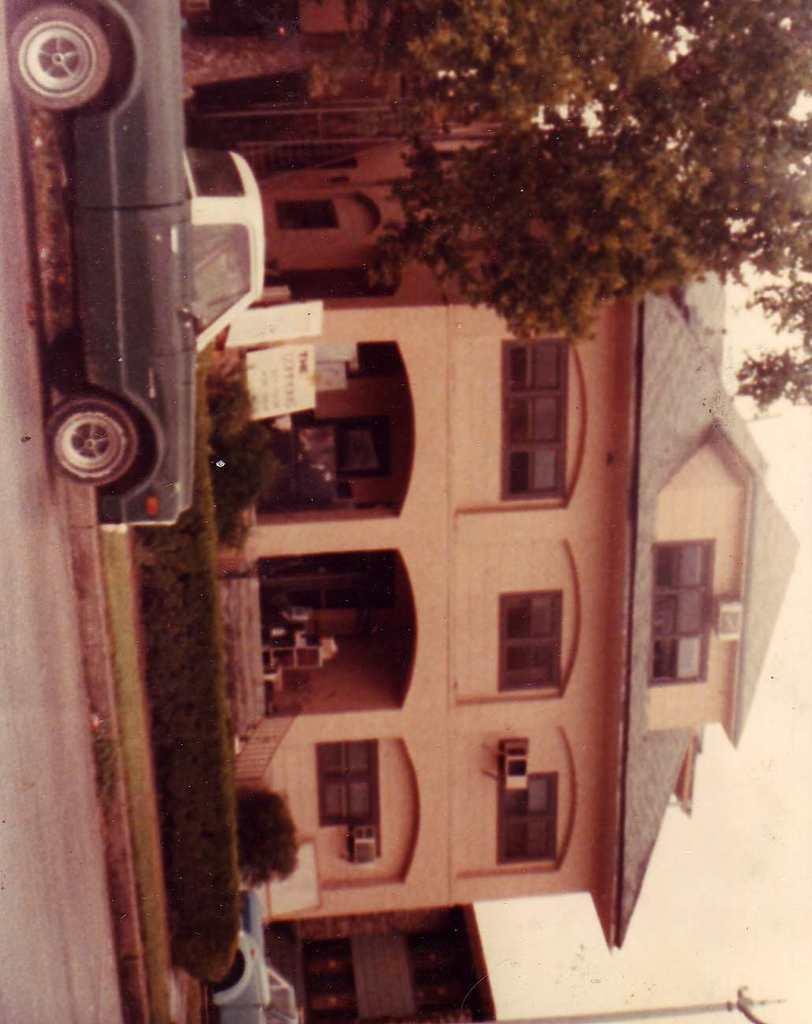Could you give a brief overview of what you see in this image? This is a vertical image, there is a building in the back with plants and trees in front of it and few cars moving on the road and above its sky. 